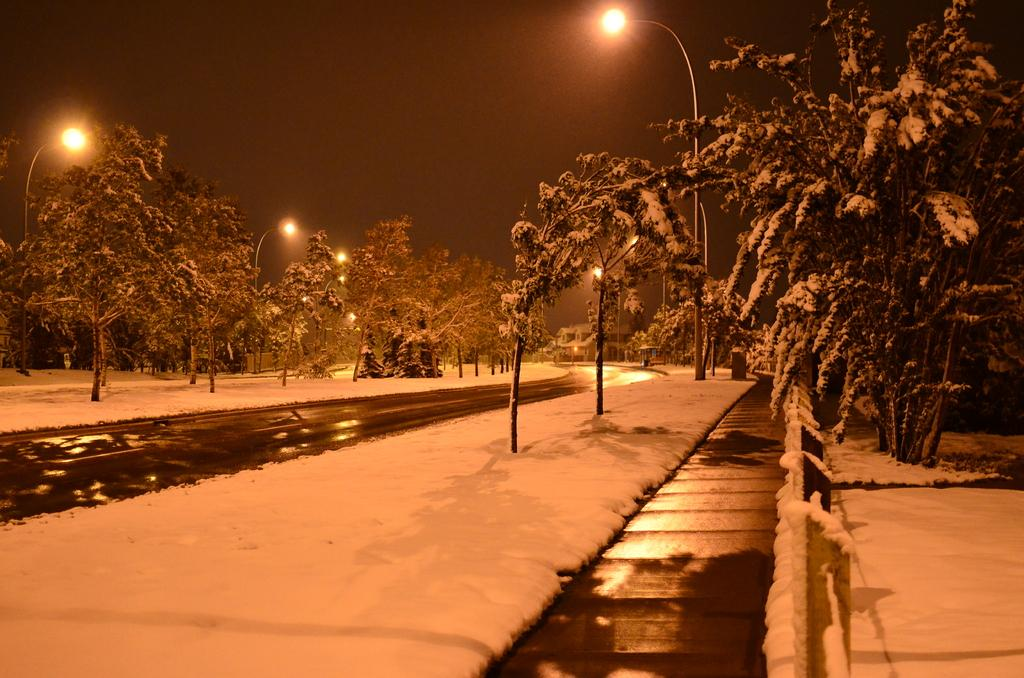What type of weather condition is depicted in the image? There is snow in the image, indicating a cold or wintry weather condition. What type of natural vegetation can be seen in the image? There are trees in the image. What type of artificial structures are present in the image? There are light poles in the image. What can be seen in the background of the image? There is a building and the sky visible in the background of the image. What type of art can be seen on the leaves of the trees in the image? There are no leaves visible in the image, as it is a snowy scene, and the trees are likely bare. Additionally, there is no mention of any art in the image. 